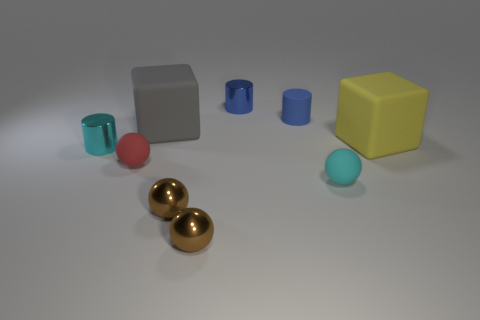What is the color of the rubber cylinder?
Give a very brief answer. Blue. Is there any other thing that has the same color as the rubber cylinder?
Your answer should be compact. Yes. There is a object that is both right of the blue matte thing and on the left side of the big yellow block; what color is it?
Ensure brevity in your answer.  Cyan. There is a cylinder in front of the gray rubber object; does it have the same size as the tiny blue metallic thing?
Your response must be concise. Yes. Are there more cyan balls that are behind the gray object than matte balls?
Make the answer very short. No. Is the red rubber object the same shape as the blue matte object?
Give a very brief answer. No. What is the size of the yellow rubber thing?
Your answer should be compact. Large. Are there more gray rubber blocks on the right side of the small cyan matte thing than tiny metal things that are on the left side of the small red rubber sphere?
Your answer should be very brief. No. Are there any small cyan objects to the left of the tiny cyan metallic cylinder?
Your answer should be very brief. No. Is there a gray object of the same size as the red thing?
Your response must be concise. No. 